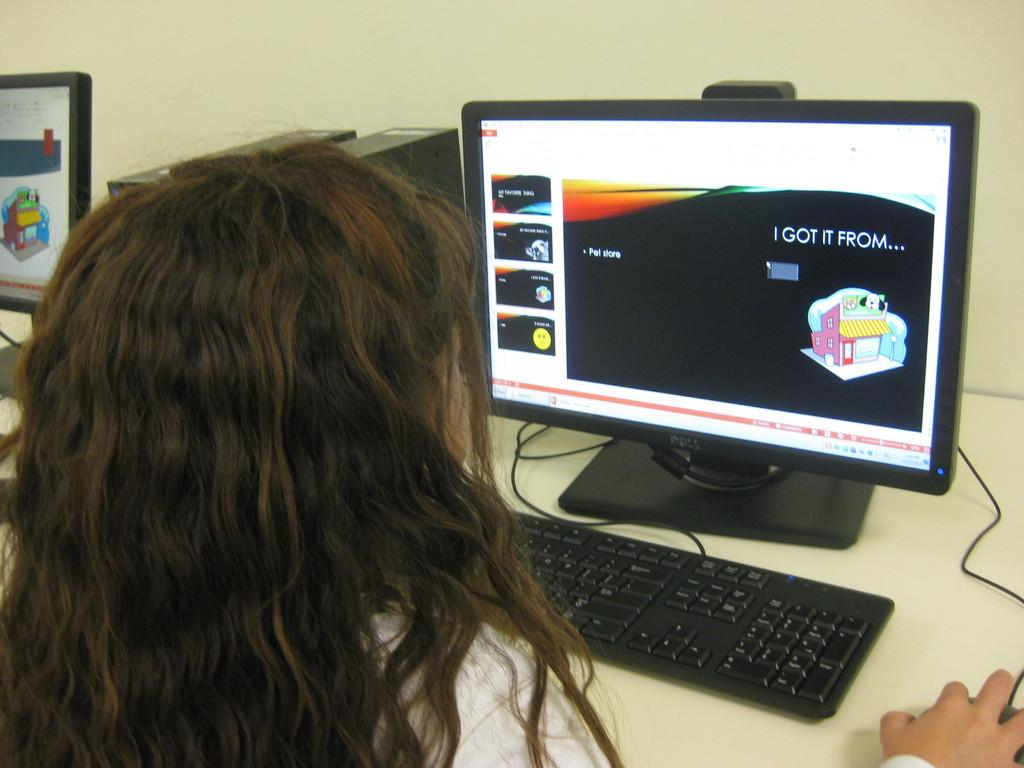<image>
Create a compact narrative representing the image presented. A woman at a computer with the words 'I got it from' on the screen. 